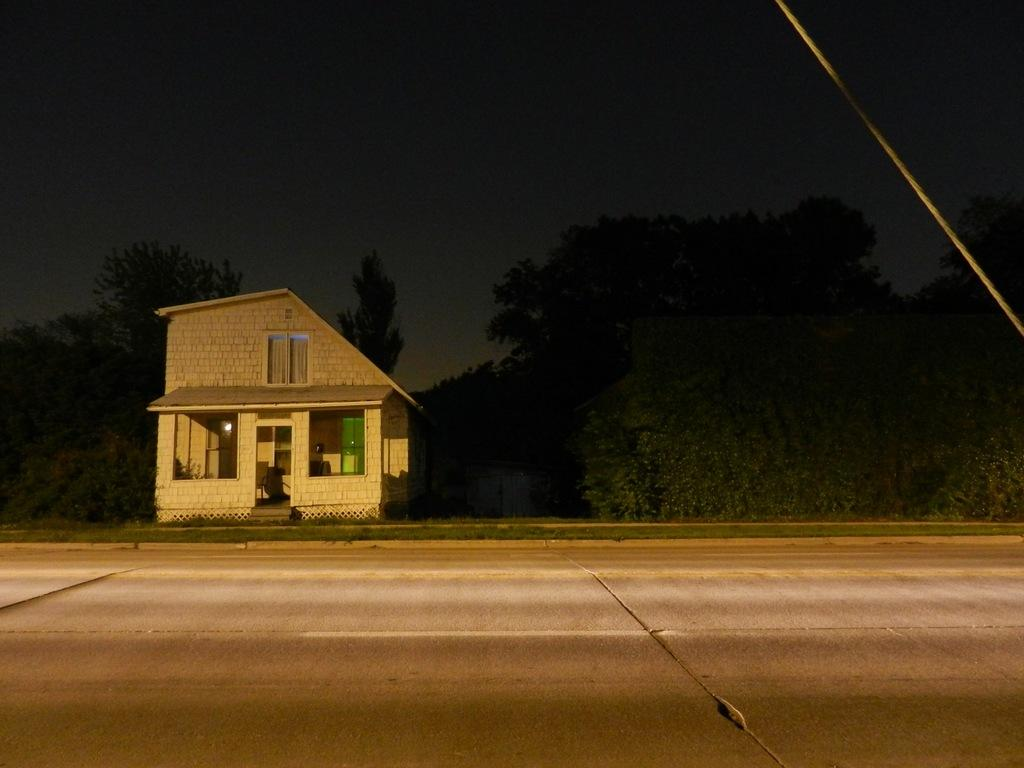What is located at the bottom of the image? There is a road at the bottom of the image. What type of structure is present in the image? There is a house in the image. What features can be seen on the house? The house has windows and a door. What is located near the house? There are trees near the house. What can be seen in the background of the image? The sky is visible in the background of the image. Can you tell me how many kitties are sitting on the roof of the house in the image? There are no kitties present on the roof of the house in the image. What type of writer is depicted in the image? There is no writer depicted in the image; it features a house, trees, and a road. 